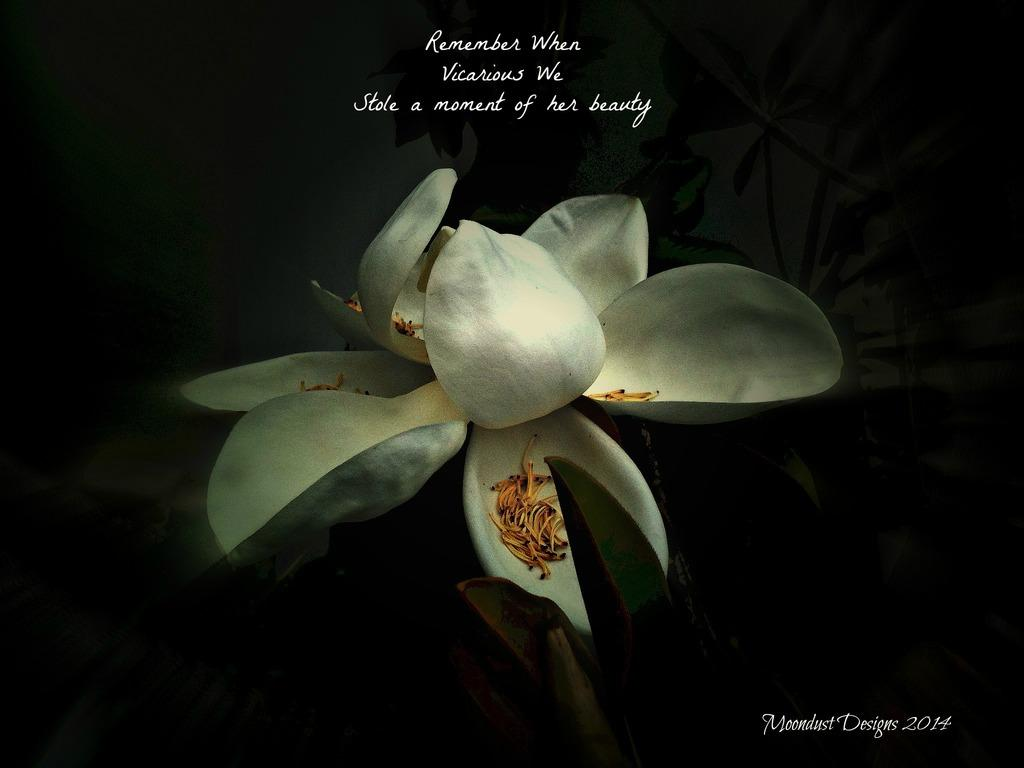What type of plant can be seen in the picture? There is a flower plant in the picture. What else is present in the picture besides the flower plant? There is text in the picture. What type of horn can be seen in the picture? There is no horn present in the picture; it features a flower plant and text. How many friends are visible in the picture? There is no mention of friends in the picture; it only contains a flower plant and text. 